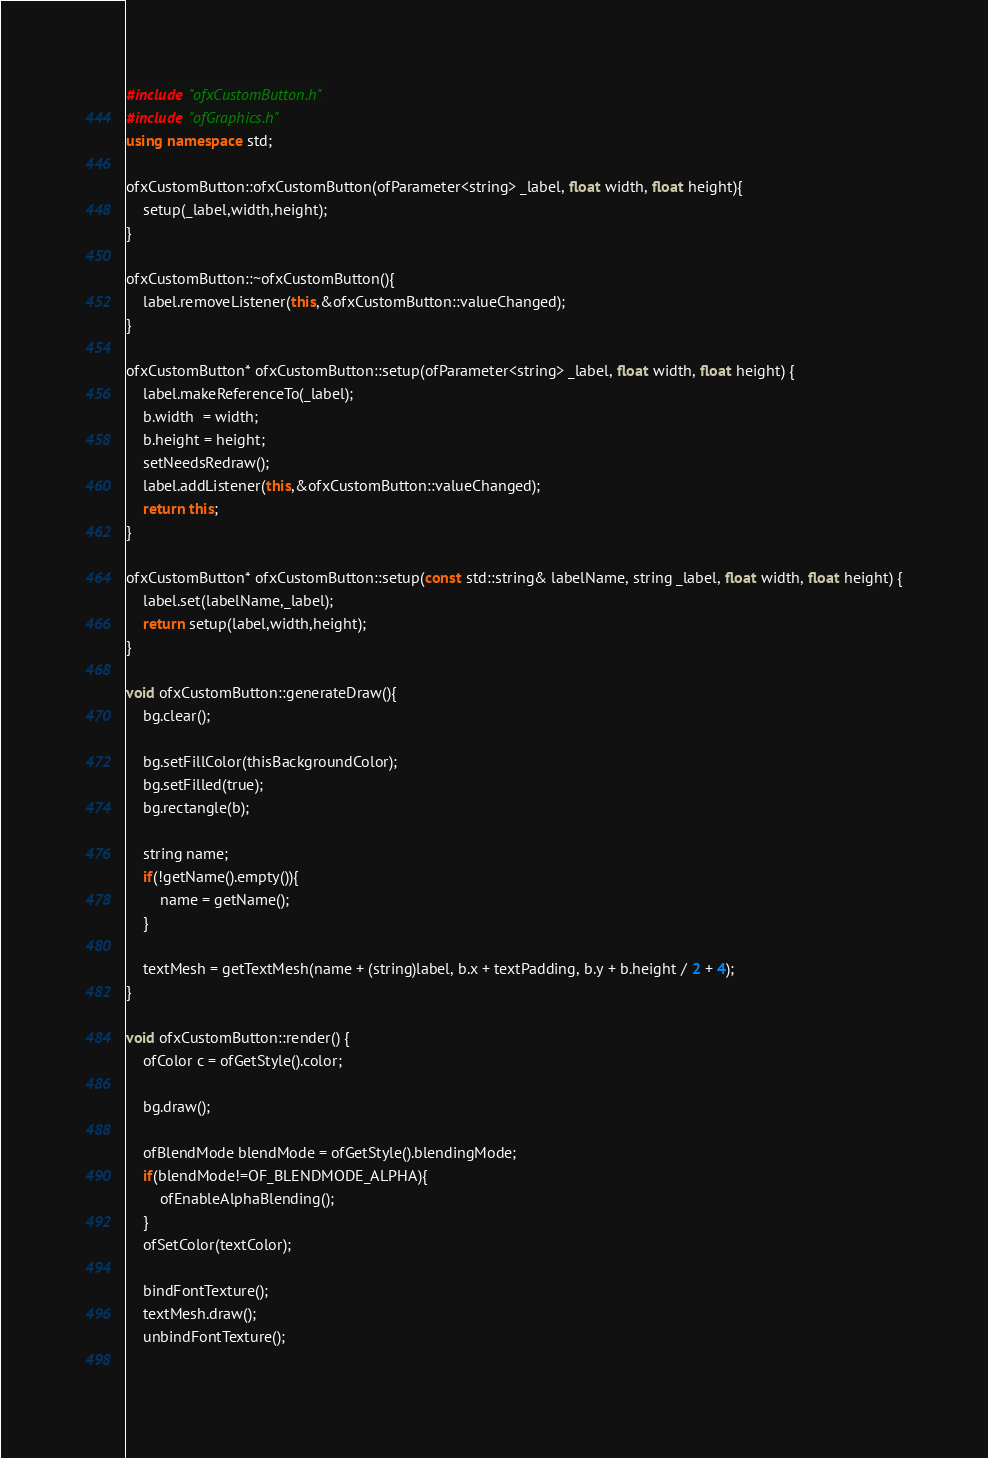<code> <loc_0><loc_0><loc_500><loc_500><_C++_>#include "ofxCustomButton.h"
#include "ofGraphics.h"
using namespace std;

ofxCustomButton::ofxCustomButton(ofParameter<string> _label, float width, float height){
    setup(_label,width,height);
}

ofxCustomButton::~ofxCustomButton(){
    label.removeListener(this,&ofxCustomButton::valueChanged);
}

ofxCustomButton* ofxCustomButton::setup(ofParameter<string> _label, float width, float height) {
    label.makeReferenceTo(_label);
    b.width  = width;
    b.height = height;
    setNeedsRedraw();
    label.addListener(this,&ofxCustomButton::valueChanged);
    return this;
}

ofxCustomButton* ofxCustomButton::setup(const std::string& labelName, string _label, float width, float height) {
    label.set(labelName,_label);
    return setup(label,width,height);
}

void ofxCustomButton::generateDraw(){
    bg.clear();
    
    bg.setFillColor(thisBackgroundColor);
    bg.setFilled(true);
    bg.rectangle(b);
    
    string name;
    if(!getName().empty()){
        name = getName();
    }
    
    textMesh = getTextMesh(name + (string)label, b.x + textPadding, b.y + b.height / 2 + 4);
}

void ofxCustomButton::render() {
    ofColor c = ofGetStyle().color;
    
    bg.draw();
    
    ofBlendMode blendMode = ofGetStyle().blendingMode;
    if(blendMode!=OF_BLENDMODE_ALPHA){
        ofEnableAlphaBlending();
    }
    ofSetColor(textColor);
    
    bindFontTexture();
    textMesh.draw();
    unbindFontTexture();
    </code> 